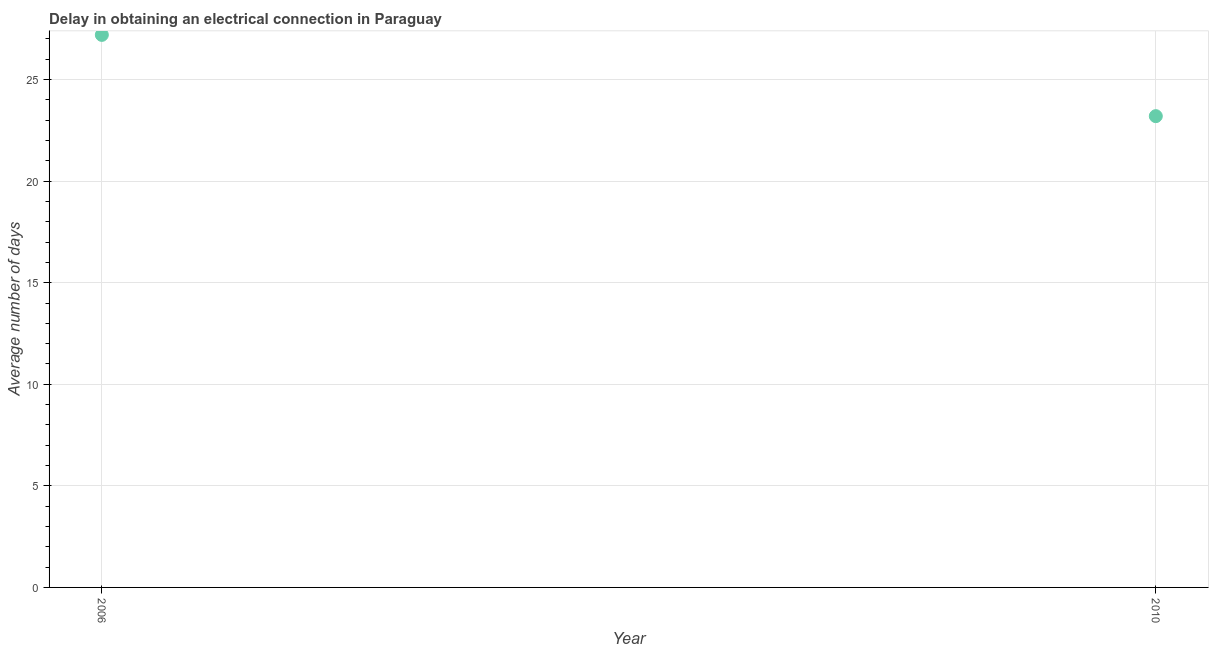What is the dalay in electrical connection in 2010?
Your answer should be very brief. 23.2. Across all years, what is the maximum dalay in electrical connection?
Offer a terse response. 27.2. Across all years, what is the minimum dalay in electrical connection?
Ensure brevity in your answer.  23.2. What is the sum of the dalay in electrical connection?
Provide a short and direct response. 50.4. What is the difference between the dalay in electrical connection in 2006 and 2010?
Your response must be concise. 4. What is the average dalay in electrical connection per year?
Offer a very short reply. 25.2. What is the median dalay in electrical connection?
Your answer should be very brief. 25.2. Do a majority of the years between 2006 and 2010 (inclusive) have dalay in electrical connection greater than 3 days?
Ensure brevity in your answer.  Yes. What is the ratio of the dalay in electrical connection in 2006 to that in 2010?
Provide a short and direct response. 1.17. How many dotlines are there?
Provide a succinct answer. 1. What is the difference between two consecutive major ticks on the Y-axis?
Ensure brevity in your answer.  5. Does the graph contain any zero values?
Provide a short and direct response. No. What is the title of the graph?
Offer a terse response. Delay in obtaining an electrical connection in Paraguay. What is the label or title of the Y-axis?
Make the answer very short. Average number of days. What is the Average number of days in 2006?
Your response must be concise. 27.2. What is the Average number of days in 2010?
Ensure brevity in your answer.  23.2. What is the ratio of the Average number of days in 2006 to that in 2010?
Give a very brief answer. 1.17. 